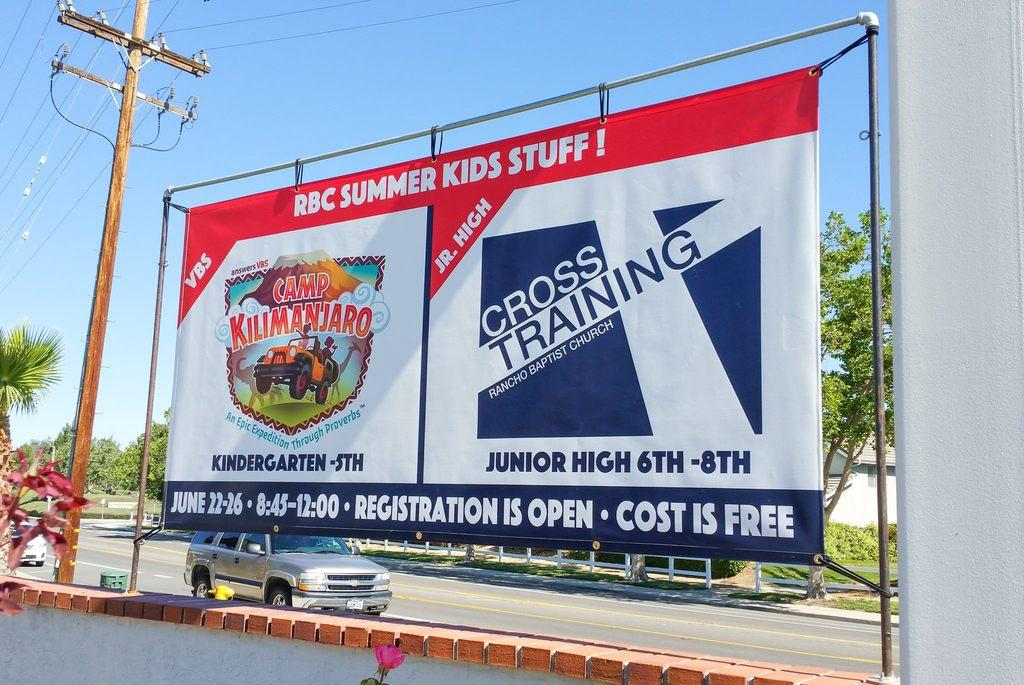<image>
Offer a succinct explanation of the picture presented. a billboard with the words BBC Summer Kids Stuff 